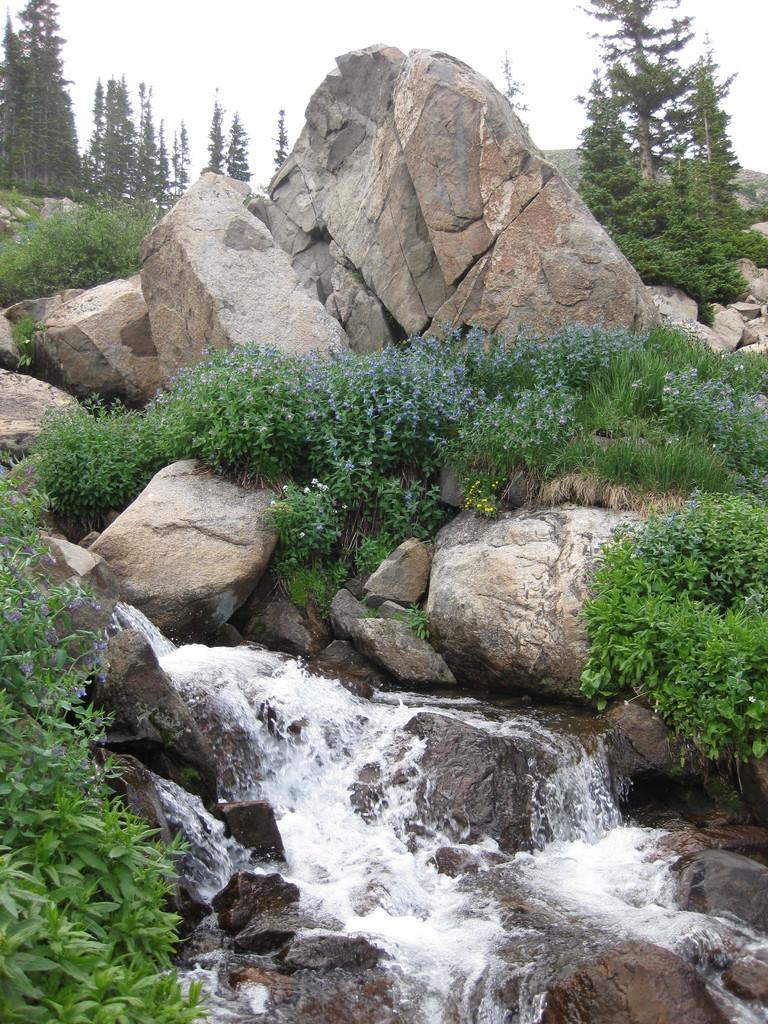How would you summarize this image in a sentence or two? In the given image i can see a rocks,water flowering,plants,trees and in the background i can see the sky. 